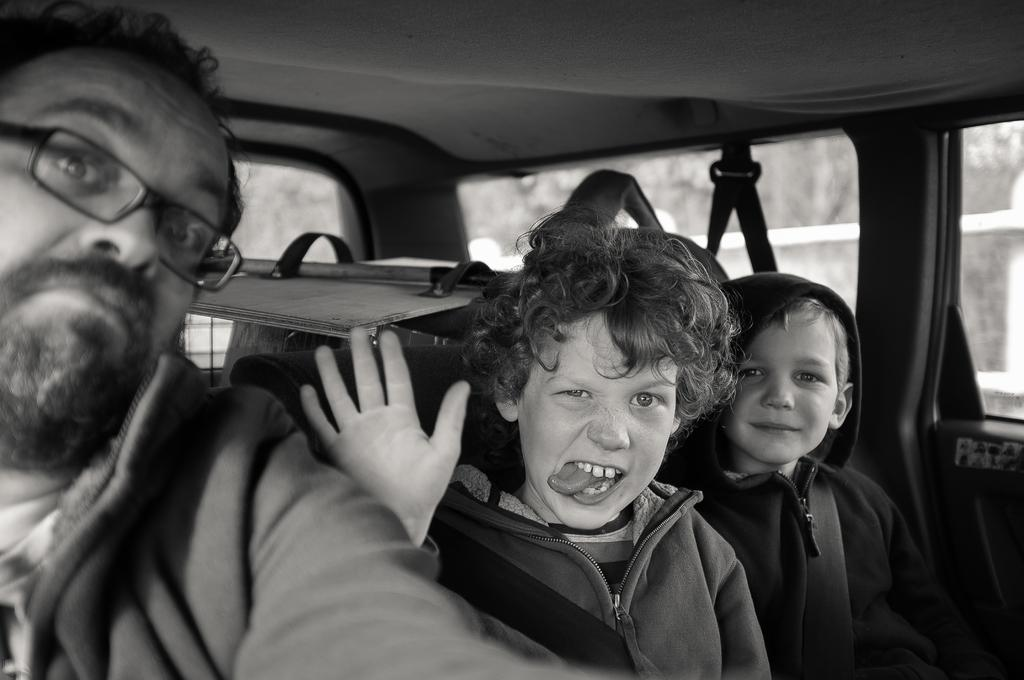What is the color scheme of the image? The image is black and white. How many people are in the image? There are three persons in the image. What are the persons doing in the image? The persons are sitting inside a vehicle and posing for a camera. Can you describe any specific detail about one of the persons? One of the men is wearing spectacles. What type of bucket can be seen in the throat of one of the persons in the image? There is no bucket or any reference to a throat in the image; it features three persons sitting inside a vehicle and posing for a camera. 